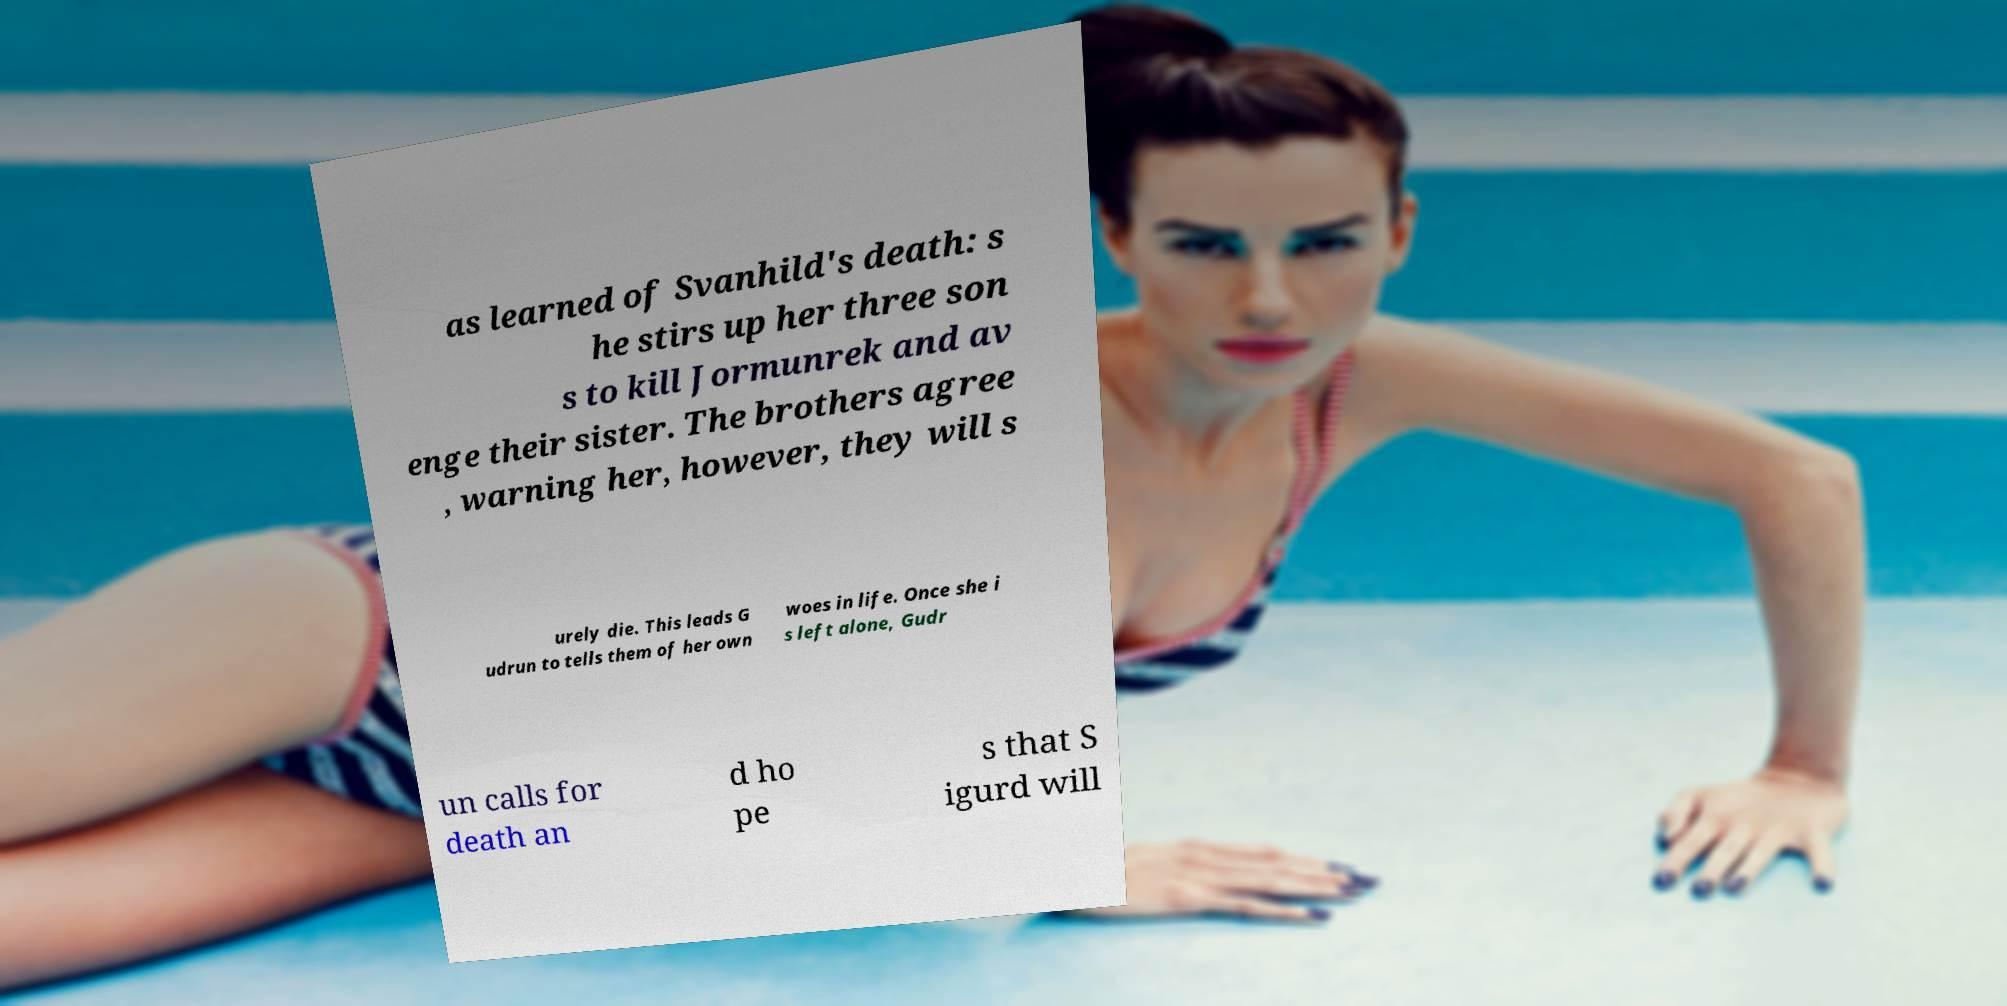Could you assist in decoding the text presented in this image and type it out clearly? as learned of Svanhild's death: s he stirs up her three son s to kill Jormunrek and av enge their sister. The brothers agree , warning her, however, they will s urely die. This leads G udrun to tells them of her own woes in life. Once she i s left alone, Gudr un calls for death an d ho pe s that S igurd will 